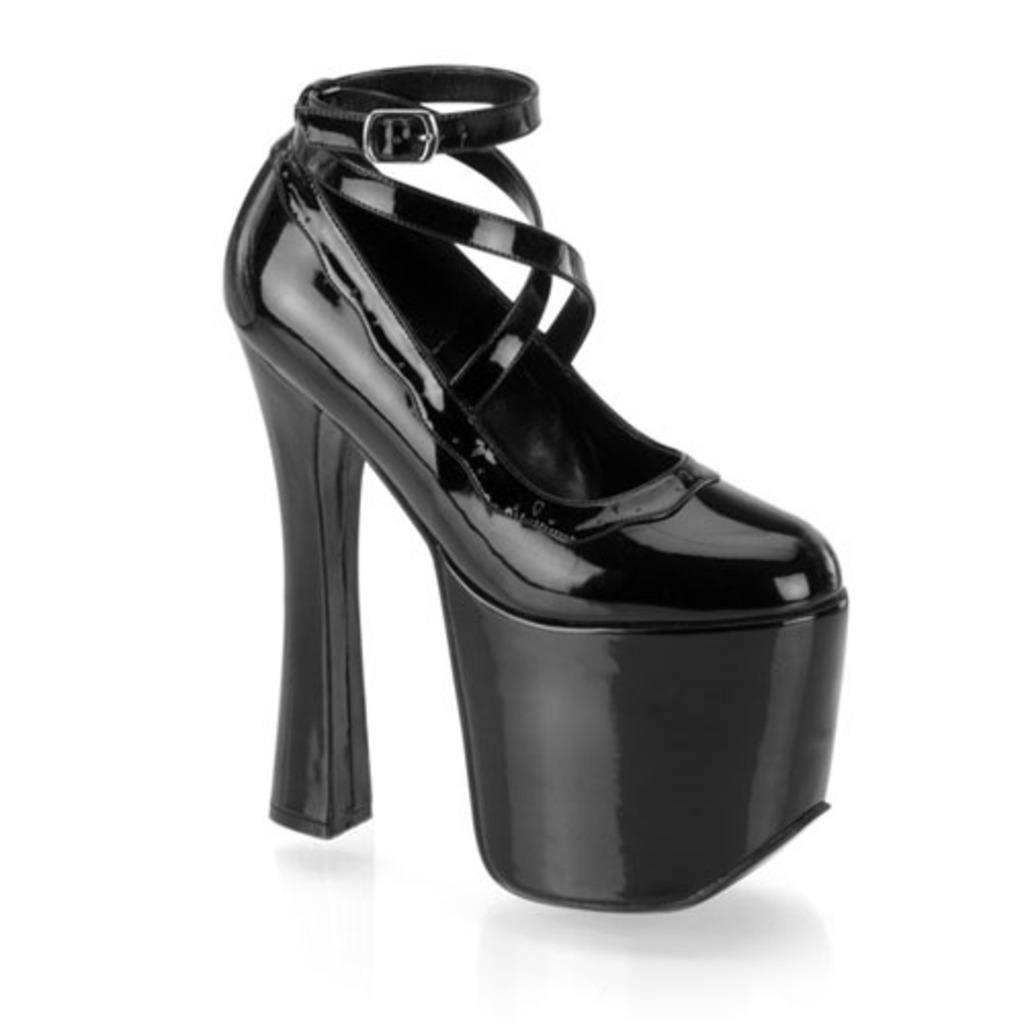What type of footwear is visible in the image? There is a sandal in the image. What color is the sandal? The sandal is black in color. What is the color of the background in the image? The background of the image is white. What is the color of the surface in the image? The surface in the image is white. How far is the park from the dock in the image? There is no park or dock present in the image, so it is not possible to determine the distance between them. 